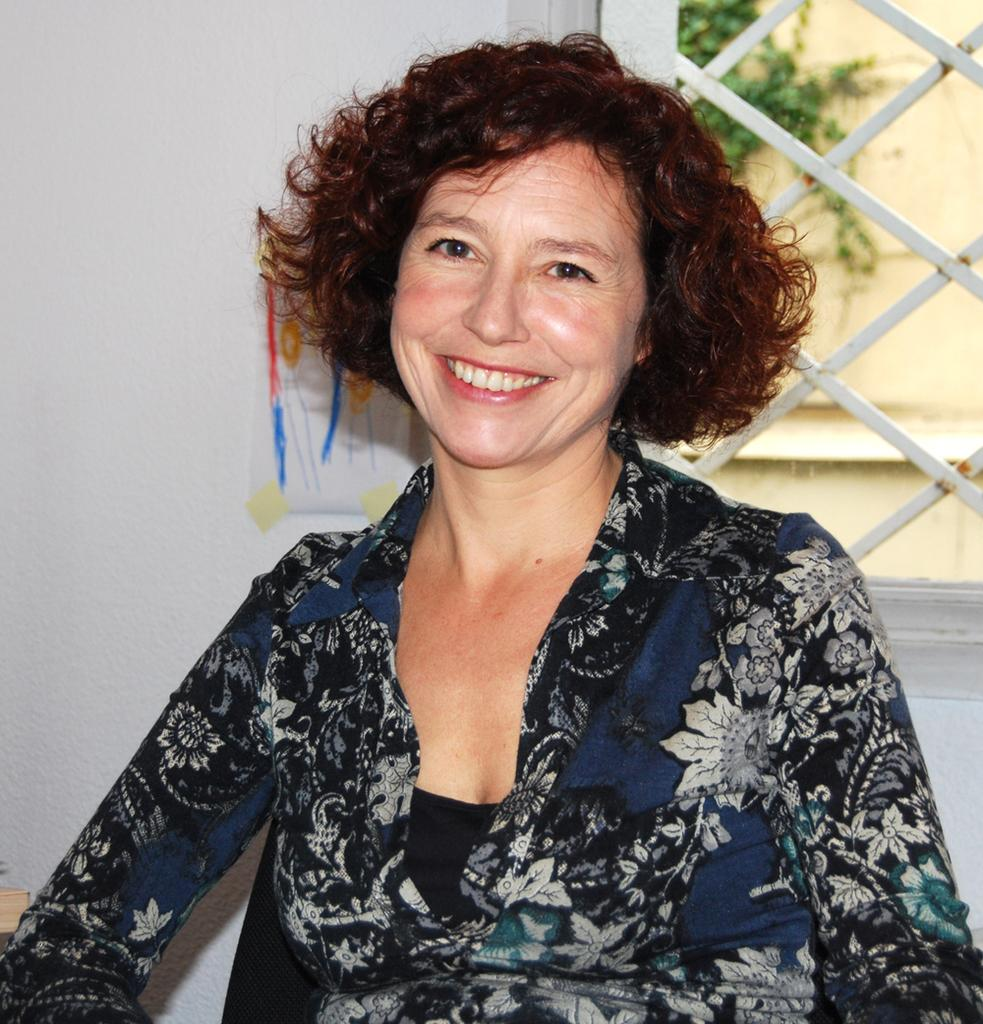What is present in the image? There is a person in the image. What can be seen in the background of the image? There is a wall and a window in the background of the image. Is there anything on the wall? Yes, there is an object on the wall. What else can be seen in the image? There is a plant visible in the image. What type of ship can be seen sailing in the background of the image? There is no ship visible in the image; the background features a wall and a window. 